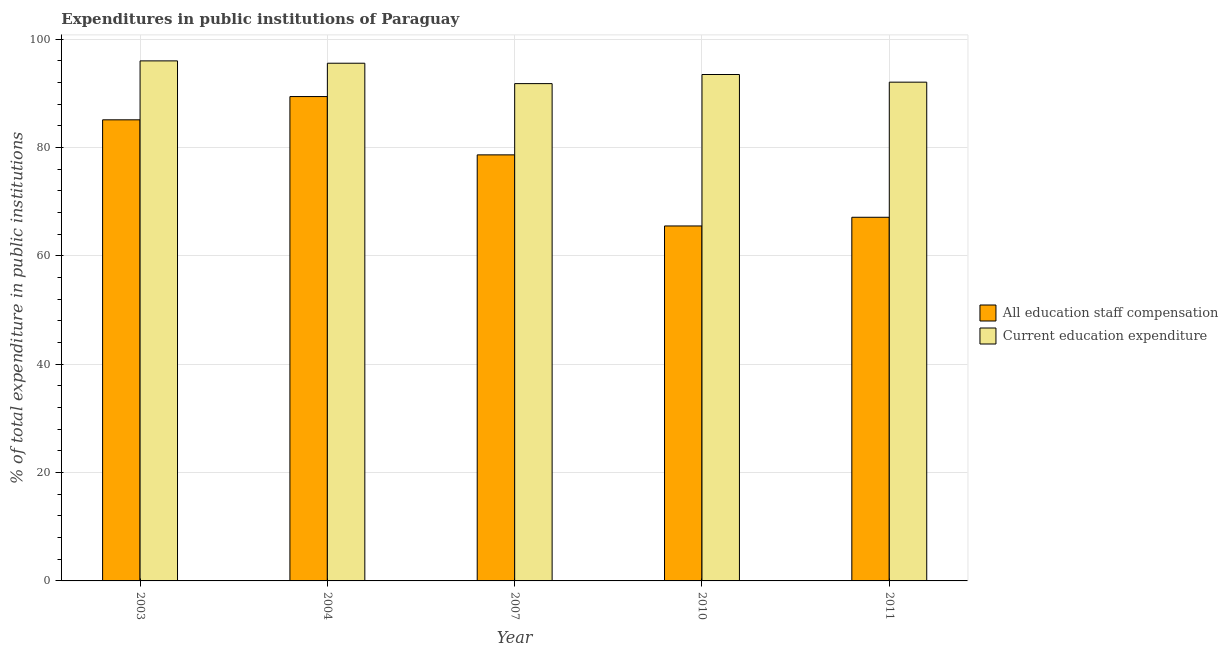How many different coloured bars are there?
Provide a succinct answer. 2. Are the number of bars on each tick of the X-axis equal?
Your answer should be compact. Yes. In how many cases, is the number of bars for a given year not equal to the number of legend labels?
Give a very brief answer. 0. What is the expenditure in staff compensation in 2004?
Keep it short and to the point. 89.41. Across all years, what is the maximum expenditure in staff compensation?
Make the answer very short. 89.41. Across all years, what is the minimum expenditure in education?
Your response must be concise. 91.8. In which year was the expenditure in staff compensation minimum?
Ensure brevity in your answer.  2010. What is the total expenditure in staff compensation in the graph?
Give a very brief answer. 385.84. What is the difference between the expenditure in education in 2003 and that in 2004?
Make the answer very short. 0.44. What is the difference between the expenditure in education in 2011 and the expenditure in staff compensation in 2010?
Your answer should be compact. -1.41. What is the average expenditure in education per year?
Your answer should be very brief. 93.78. What is the ratio of the expenditure in education in 2003 to that in 2010?
Make the answer very short. 1.03. Is the difference between the expenditure in education in 2003 and 2011 greater than the difference between the expenditure in staff compensation in 2003 and 2011?
Give a very brief answer. No. What is the difference between the highest and the second highest expenditure in education?
Provide a succinct answer. 0.44. What is the difference between the highest and the lowest expenditure in staff compensation?
Provide a short and direct response. 23.89. What does the 1st bar from the left in 2003 represents?
Your response must be concise. All education staff compensation. What does the 2nd bar from the right in 2003 represents?
Give a very brief answer. All education staff compensation. How many bars are there?
Offer a very short reply. 10. How many years are there in the graph?
Give a very brief answer. 5. What is the difference between two consecutive major ticks on the Y-axis?
Your answer should be compact. 20. Does the graph contain any zero values?
Your answer should be very brief. No. Does the graph contain grids?
Give a very brief answer. Yes. What is the title of the graph?
Offer a very short reply. Expenditures in public institutions of Paraguay. Does "Official aid received" appear as one of the legend labels in the graph?
Ensure brevity in your answer.  No. What is the label or title of the X-axis?
Provide a succinct answer. Year. What is the label or title of the Y-axis?
Keep it short and to the point. % of total expenditure in public institutions. What is the % of total expenditure in public institutions of All education staff compensation in 2003?
Your response must be concise. 85.12. What is the % of total expenditure in public institutions of Current education expenditure in 2003?
Your response must be concise. 96. What is the % of total expenditure in public institutions of All education staff compensation in 2004?
Offer a very short reply. 89.41. What is the % of total expenditure in public institutions in Current education expenditure in 2004?
Offer a terse response. 95.57. What is the % of total expenditure in public institutions in All education staff compensation in 2007?
Your answer should be compact. 78.65. What is the % of total expenditure in public institutions of Current education expenditure in 2007?
Your response must be concise. 91.8. What is the % of total expenditure in public institutions of All education staff compensation in 2010?
Give a very brief answer. 65.53. What is the % of total expenditure in public institutions of Current education expenditure in 2010?
Offer a very short reply. 93.48. What is the % of total expenditure in public institutions of All education staff compensation in 2011?
Offer a very short reply. 67.13. What is the % of total expenditure in public institutions in Current education expenditure in 2011?
Ensure brevity in your answer.  92.07. Across all years, what is the maximum % of total expenditure in public institutions of All education staff compensation?
Your response must be concise. 89.41. Across all years, what is the maximum % of total expenditure in public institutions of Current education expenditure?
Make the answer very short. 96. Across all years, what is the minimum % of total expenditure in public institutions of All education staff compensation?
Your answer should be very brief. 65.53. Across all years, what is the minimum % of total expenditure in public institutions of Current education expenditure?
Provide a succinct answer. 91.8. What is the total % of total expenditure in public institutions in All education staff compensation in the graph?
Your answer should be compact. 385.84. What is the total % of total expenditure in public institutions of Current education expenditure in the graph?
Your answer should be very brief. 468.92. What is the difference between the % of total expenditure in public institutions of All education staff compensation in 2003 and that in 2004?
Give a very brief answer. -4.3. What is the difference between the % of total expenditure in public institutions of Current education expenditure in 2003 and that in 2004?
Your response must be concise. 0.44. What is the difference between the % of total expenditure in public institutions of All education staff compensation in 2003 and that in 2007?
Offer a terse response. 6.47. What is the difference between the % of total expenditure in public institutions of Current education expenditure in 2003 and that in 2007?
Offer a terse response. 4.2. What is the difference between the % of total expenditure in public institutions of All education staff compensation in 2003 and that in 2010?
Your answer should be compact. 19.59. What is the difference between the % of total expenditure in public institutions of Current education expenditure in 2003 and that in 2010?
Your answer should be compact. 2.52. What is the difference between the % of total expenditure in public institutions of All education staff compensation in 2003 and that in 2011?
Offer a very short reply. 17.99. What is the difference between the % of total expenditure in public institutions in Current education expenditure in 2003 and that in 2011?
Ensure brevity in your answer.  3.93. What is the difference between the % of total expenditure in public institutions in All education staff compensation in 2004 and that in 2007?
Your answer should be compact. 10.76. What is the difference between the % of total expenditure in public institutions in Current education expenditure in 2004 and that in 2007?
Give a very brief answer. 3.76. What is the difference between the % of total expenditure in public institutions of All education staff compensation in 2004 and that in 2010?
Provide a short and direct response. 23.89. What is the difference between the % of total expenditure in public institutions of Current education expenditure in 2004 and that in 2010?
Keep it short and to the point. 2.08. What is the difference between the % of total expenditure in public institutions in All education staff compensation in 2004 and that in 2011?
Your answer should be compact. 22.29. What is the difference between the % of total expenditure in public institutions of Current education expenditure in 2004 and that in 2011?
Offer a terse response. 3.49. What is the difference between the % of total expenditure in public institutions of All education staff compensation in 2007 and that in 2010?
Your answer should be compact. 13.12. What is the difference between the % of total expenditure in public institutions in Current education expenditure in 2007 and that in 2010?
Give a very brief answer. -1.68. What is the difference between the % of total expenditure in public institutions of All education staff compensation in 2007 and that in 2011?
Your answer should be very brief. 11.52. What is the difference between the % of total expenditure in public institutions in Current education expenditure in 2007 and that in 2011?
Your answer should be very brief. -0.27. What is the difference between the % of total expenditure in public institutions in All education staff compensation in 2010 and that in 2011?
Your answer should be very brief. -1.6. What is the difference between the % of total expenditure in public institutions of Current education expenditure in 2010 and that in 2011?
Provide a short and direct response. 1.41. What is the difference between the % of total expenditure in public institutions of All education staff compensation in 2003 and the % of total expenditure in public institutions of Current education expenditure in 2004?
Keep it short and to the point. -10.45. What is the difference between the % of total expenditure in public institutions of All education staff compensation in 2003 and the % of total expenditure in public institutions of Current education expenditure in 2007?
Your answer should be compact. -6.68. What is the difference between the % of total expenditure in public institutions of All education staff compensation in 2003 and the % of total expenditure in public institutions of Current education expenditure in 2010?
Keep it short and to the point. -8.37. What is the difference between the % of total expenditure in public institutions in All education staff compensation in 2003 and the % of total expenditure in public institutions in Current education expenditure in 2011?
Your answer should be compact. -6.95. What is the difference between the % of total expenditure in public institutions in All education staff compensation in 2004 and the % of total expenditure in public institutions in Current education expenditure in 2007?
Offer a terse response. -2.39. What is the difference between the % of total expenditure in public institutions of All education staff compensation in 2004 and the % of total expenditure in public institutions of Current education expenditure in 2010?
Your response must be concise. -4.07. What is the difference between the % of total expenditure in public institutions of All education staff compensation in 2004 and the % of total expenditure in public institutions of Current education expenditure in 2011?
Your answer should be compact. -2.66. What is the difference between the % of total expenditure in public institutions of All education staff compensation in 2007 and the % of total expenditure in public institutions of Current education expenditure in 2010?
Offer a terse response. -14.83. What is the difference between the % of total expenditure in public institutions in All education staff compensation in 2007 and the % of total expenditure in public institutions in Current education expenditure in 2011?
Keep it short and to the point. -13.42. What is the difference between the % of total expenditure in public institutions of All education staff compensation in 2010 and the % of total expenditure in public institutions of Current education expenditure in 2011?
Provide a succinct answer. -26.54. What is the average % of total expenditure in public institutions in All education staff compensation per year?
Keep it short and to the point. 77.17. What is the average % of total expenditure in public institutions in Current education expenditure per year?
Provide a short and direct response. 93.78. In the year 2003, what is the difference between the % of total expenditure in public institutions in All education staff compensation and % of total expenditure in public institutions in Current education expenditure?
Ensure brevity in your answer.  -10.88. In the year 2004, what is the difference between the % of total expenditure in public institutions of All education staff compensation and % of total expenditure in public institutions of Current education expenditure?
Offer a terse response. -6.15. In the year 2007, what is the difference between the % of total expenditure in public institutions in All education staff compensation and % of total expenditure in public institutions in Current education expenditure?
Provide a short and direct response. -13.15. In the year 2010, what is the difference between the % of total expenditure in public institutions in All education staff compensation and % of total expenditure in public institutions in Current education expenditure?
Offer a very short reply. -27.96. In the year 2011, what is the difference between the % of total expenditure in public institutions of All education staff compensation and % of total expenditure in public institutions of Current education expenditure?
Your answer should be compact. -24.94. What is the ratio of the % of total expenditure in public institutions in All education staff compensation in 2003 to that in 2004?
Provide a succinct answer. 0.95. What is the ratio of the % of total expenditure in public institutions of Current education expenditure in 2003 to that in 2004?
Provide a succinct answer. 1. What is the ratio of the % of total expenditure in public institutions in All education staff compensation in 2003 to that in 2007?
Offer a very short reply. 1.08. What is the ratio of the % of total expenditure in public institutions in Current education expenditure in 2003 to that in 2007?
Your answer should be compact. 1.05. What is the ratio of the % of total expenditure in public institutions in All education staff compensation in 2003 to that in 2010?
Ensure brevity in your answer.  1.3. What is the ratio of the % of total expenditure in public institutions in Current education expenditure in 2003 to that in 2010?
Provide a succinct answer. 1.03. What is the ratio of the % of total expenditure in public institutions in All education staff compensation in 2003 to that in 2011?
Offer a very short reply. 1.27. What is the ratio of the % of total expenditure in public institutions of Current education expenditure in 2003 to that in 2011?
Your response must be concise. 1.04. What is the ratio of the % of total expenditure in public institutions of All education staff compensation in 2004 to that in 2007?
Your response must be concise. 1.14. What is the ratio of the % of total expenditure in public institutions in Current education expenditure in 2004 to that in 2007?
Make the answer very short. 1.04. What is the ratio of the % of total expenditure in public institutions in All education staff compensation in 2004 to that in 2010?
Offer a very short reply. 1.36. What is the ratio of the % of total expenditure in public institutions in Current education expenditure in 2004 to that in 2010?
Provide a succinct answer. 1.02. What is the ratio of the % of total expenditure in public institutions in All education staff compensation in 2004 to that in 2011?
Your response must be concise. 1.33. What is the ratio of the % of total expenditure in public institutions in Current education expenditure in 2004 to that in 2011?
Give a very brief answer. 1.04. What is the ratio of the % of total expenditure in public institutions in All education staff compensation in 2007 to that in 2010?
Your response must be concise. 1.2. What is the ratio of the % of total expenditure in public institutions of Current education expenditure in 2007 to that in 2010?
Your answer should be very brief. 0.98. What is the ratio of the % of total expenditure in public institutions of All education staff compensation in 2007 to that in 2011?
Give a very brief answer. 1.17. What is the ratio of the % of total expenditure in public institutions of All education staff compensation in 2010 to that in 2011?
Your answer should be compact. 0.98. What is the ratio of the % of total expenditure in public institutions in Current education expenditure in 2010 to that in 2011?
Give a very brief answer. 1.02. What is the difference between the highest and the second highest % of total expenditure in public institutions in All education staff compensation?
Make the answer very short. 4.3. What is the difference between the highest and the second highest % of total expenditure in public institutions of Current education expenditure?
Offer a very short reply. 0.44. What is the difference between the highest and the lowest % of total expenditure in public institutions of All education staff compensation?
Your answer should be compact. 23.89. What is the difference between the highest and the lowest % of total expenditure in public institutions of Current education expenditure?
Ensure brevity in your answer.  4.2. 